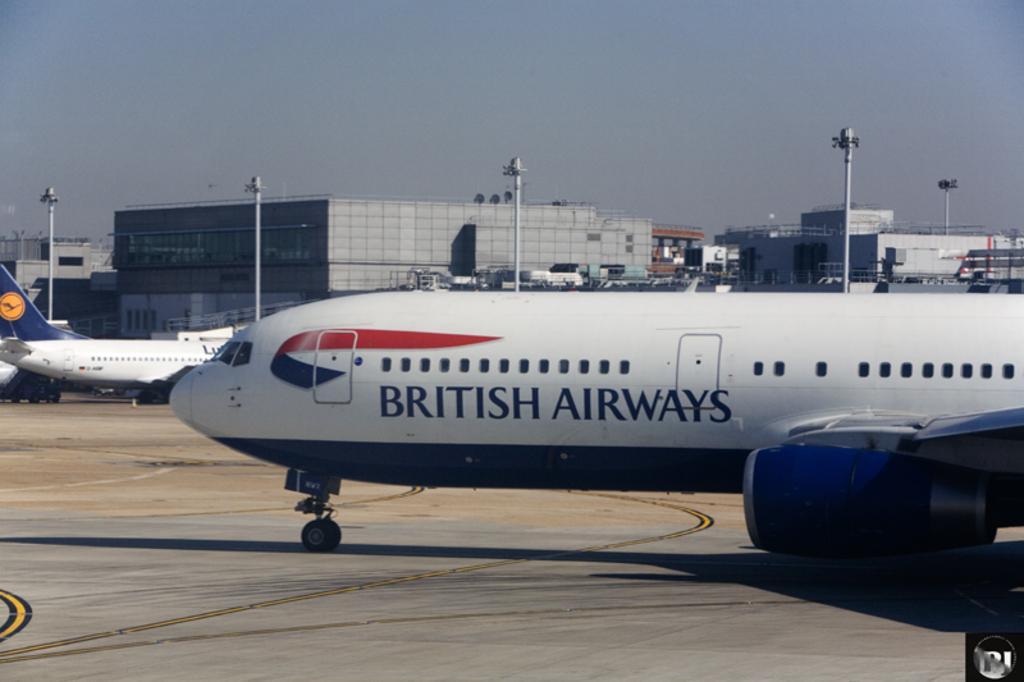What is the main subject of the image? The main subject of the image is airplanes. What else can be seen in the image besides airplanes? There are buildings, grills, and poles with lights visible in the image. What is the background of the image? The sky is visible in the background of the image. What type of jam is being spread on the bridge in the image? There is no jam or bridge present in the image; it features airplanes, buildings, grills, and poles with lights. 